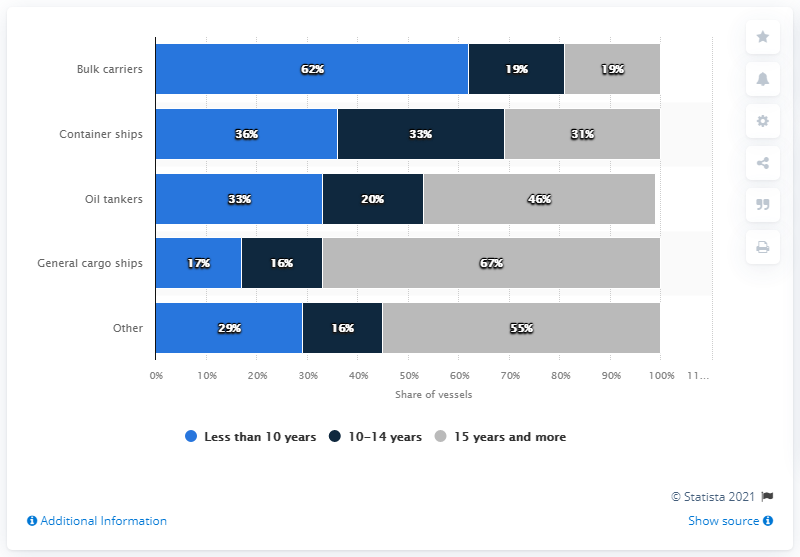Indicate a few pertinent items in this graphic. The maximum and minimum percentage share of a particular firm in the market over a 10-14 year period can differ significantly. According to data, the percentage share of bulk carriers in the global fleet has declined significantly in the past decade. Specifically, the share of this type of ship has decreased from 22.4% in 2010 to 18.1% in 2020. 